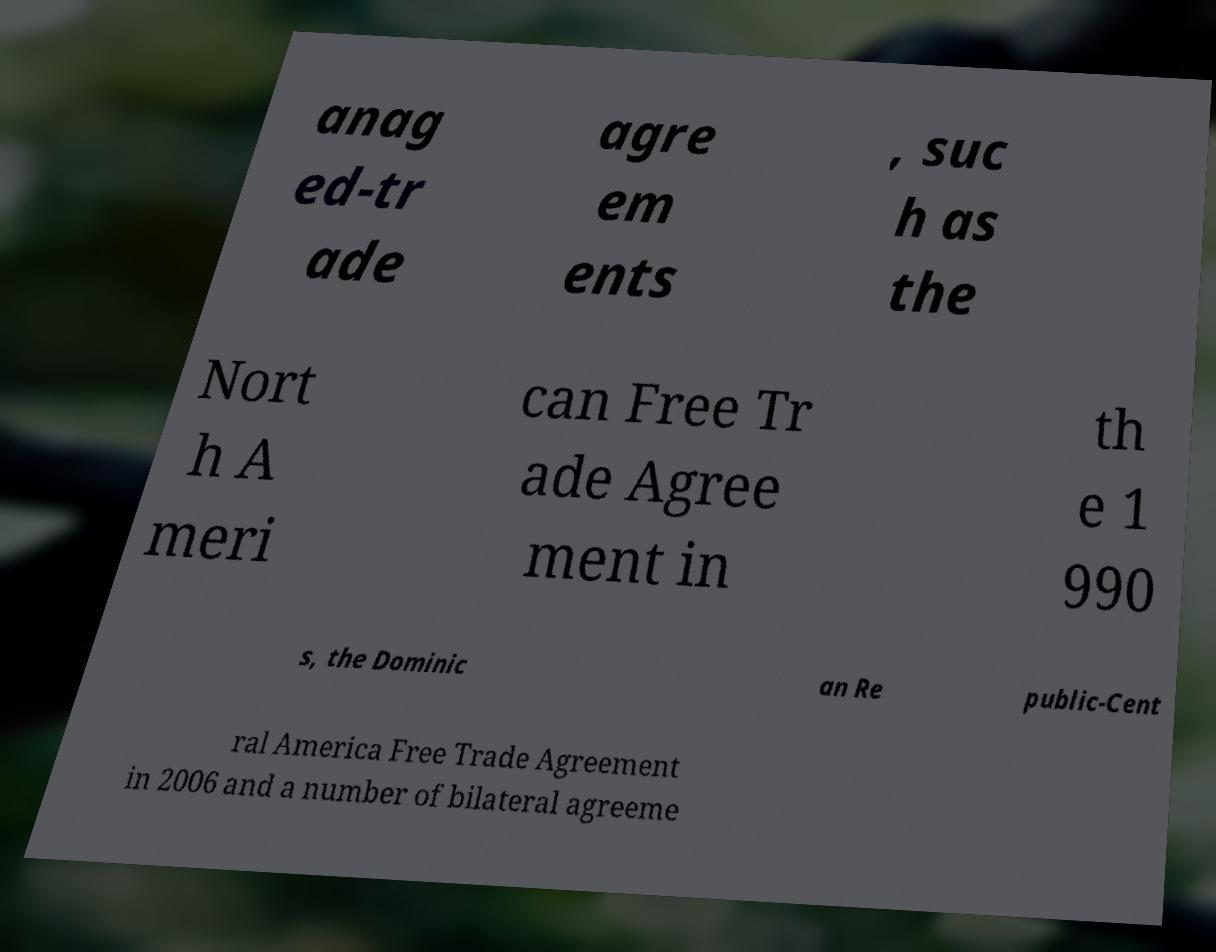For documentation purposes, I need the text within this image transcribed. Could you provide that? anag ed-tr ade agre em ents , suc h as the Nort h A meri can Free Tr ade Agree ment in th e 1 990 s, the Dominic an Re public-Cent ral America Free Trade Agreement in 2006 and a number of bilateral agreeme 